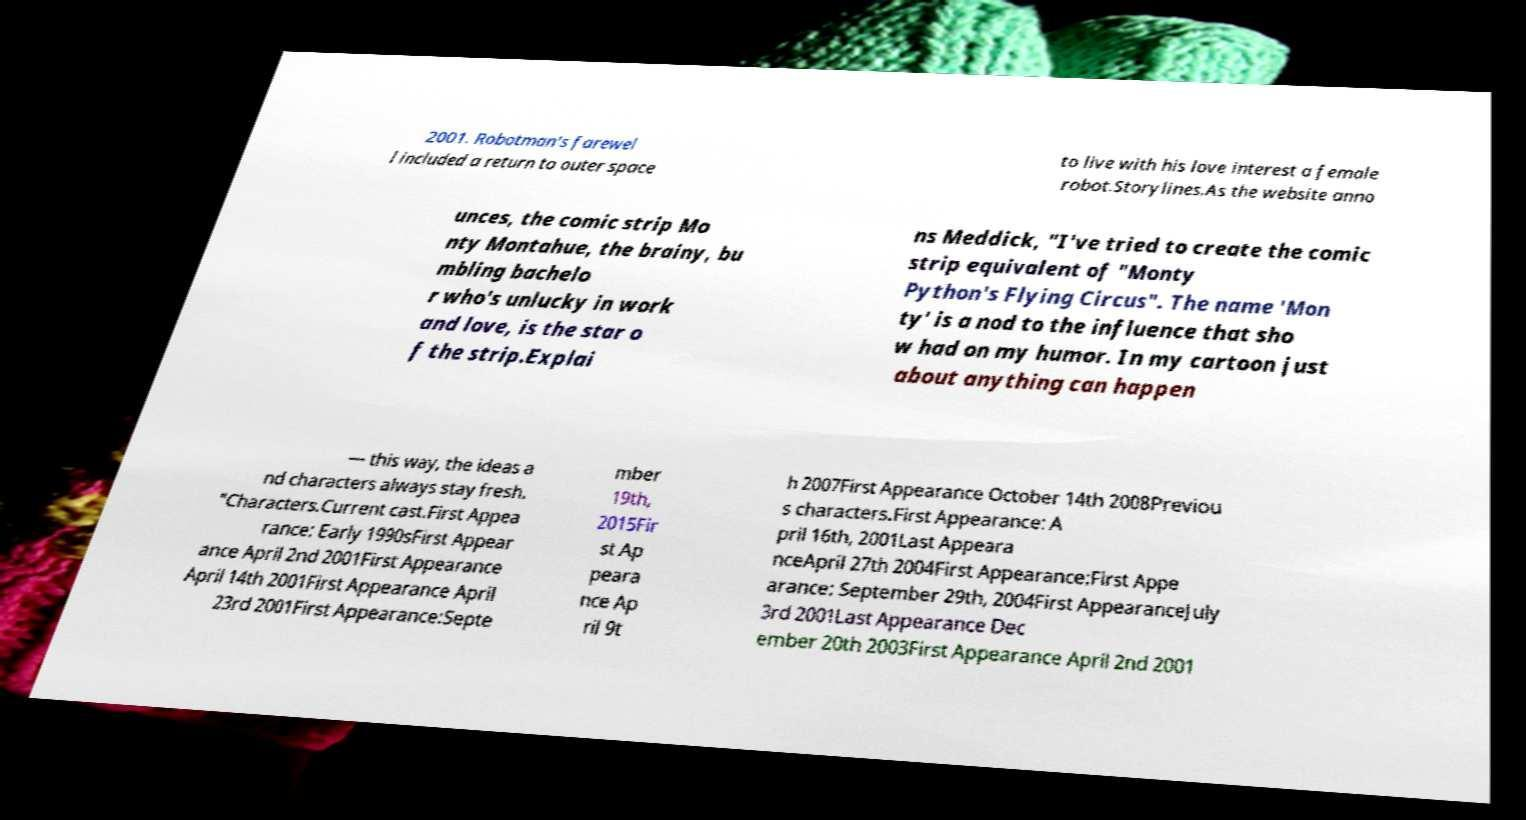Please read and relay the text visible in this image. What does it say? 2001. Robotman's farewel l included a return to outer space to live with his love interest a female robot.Storylines.As the website anno unces, the comic strip Mo nty Montahue, the brainy, bu mbling bachelo r who's unlucky in work and love, is the star o f the strip.Explai ns Meddick, "I've tried to create the comic strip equivalent of "Monty Python's Flying Circus". The name 'Mon ty' is a nod to the influence that sho w had on my humor. In my cartoon just about anything can happen — this way, the ideas a nd characters always stay fresh. "Characters.Current cast.First Appea rance: Early 1990sFirst Appear ance April 2nd 2001First Appearance April 14th 2001First Appearance April 23rd 2001First Appearance:Septe mber 19th, 2015Fir st Ap peara nce Ap ril 9t h 2007First Appearance October 14th 2008Previou s characters.First Appearance: A pril 16th, 2001Last Appeara nceApril 27th 2004First Appearance:First Appe arance: September 29th, 2004First AppearanceJuly 3rd 2001Last Appearance Dec ember 20th 2003First Appearance April 2nd 2001 